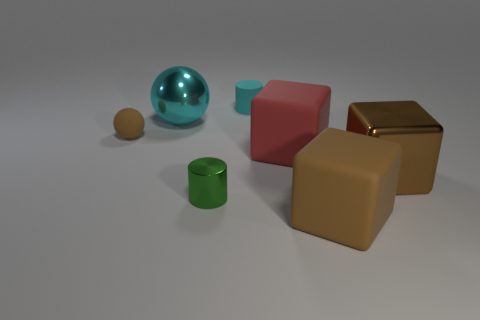Subtract all yellow cylinders. How many brown cubes are left? 2 Add 3 large yellow spheres. How many objects exist? 10 Subtract all brown rubber cubes. How many cubes are left? 2 Add 1 small green cylinders. How many small green cylinders exist? 2 Subtract 0 gray cylinders. How many objects are left? 7 Subtract all cylinders. How many objects are left? 5 Subtract all tiny spheres. Subtract all big matte blocks. How many objects are left? 4 Add 7 cyan objects. How many cyan objects are left? 9 